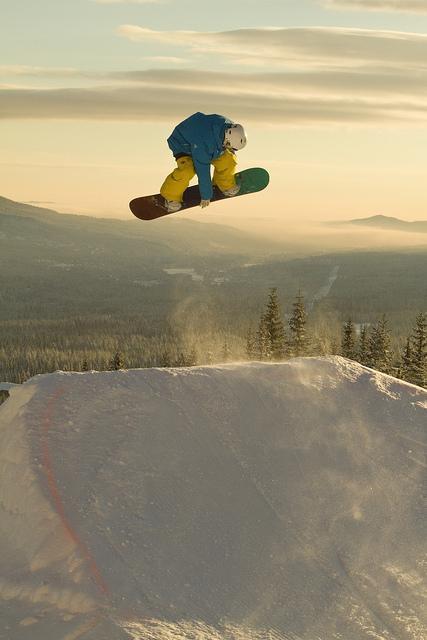How many zebras in the picture?
Give a very brief answer. 0. 